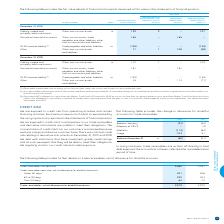According to Bce's financial document, How is the maximum exposure to credit risk represented? represented by the carrying amounts reported in the statements of financial position. The document states: "cing activities, the maximum exposure of which is represented by the carrying amounts reported in the statements of financial position...." Also, Why is the concentration of credit risk from customers minimized? because we have a large and diverse customer base. The document states: "on of credit risk from our customers is minimized because we have a large and diverse customer base. There was minimal credit risk relating to derivat..." Also, What are the periods considered in this context? The document shows two values: 2019 and 2018. From the document: "NOTE 2019 2018 NOTE 2019 2018..." Additionally, Which year was the amount for Usage larger? According to the financial document, 2019. The relevant text states: "NOTE 2019 2018..." Also, can you calculate: What is the change in the amount for Usage in 2019? Based on the calculation: 103-91, the result is 12. This is based on the information: "Usage 103 91 Usage 103 91..." The key data points involved are: 103, 91. Also, can you calculate: What is the average amount of Usage in 2018 and 2019? To answer this question, I need to perform calculations using the financial data. The calculation is: (103+91)/2, which equals 97. This is based on the information: "Usage 103 91 Usage 103 91..." The key data points involved are: 103, 91. 